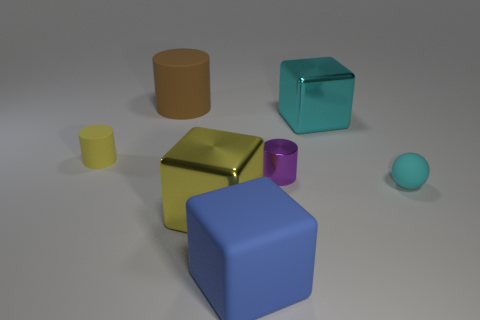What is the material of the big yellow object that is the same shape as the blue rubber object?
Your answer should be compact. Metal. Is there anything else that has the same material as the small purple object?
Your answer should be compact. Yes. What material is the big thing that is behind the small cyan object and in front of the large rubber cylinder?
Give a very brief answer. Metal. How many cyan objects are the same shape as the yellow rubber thing?
Offer a terse response. 0. The object that is behind the cyan thing on the left side of the cyan sphere is what color?
Offer a terse response. Brown. Is the number of small cyan balls behind the small purple cylinder the same as the number of small gray metal cylinders?
Make the answer very short. Yes. Is there a gray metallic object of the same size as the blue rubber cube?
Offer a terse response. No. There is a cyan metal block; is it the same size as the cylinder in front of the yellow matte thing?
Your answer should be compact. No. Are there an equal number of large brown rubber cylinders that are behind the brown object and cyan balls on the left side of the tiny purple shiny cylinder?
Offer a terse response. Yes. There is a thing that is the same color as the ball; what shape is it?
Give a very brief answer. Cube. 